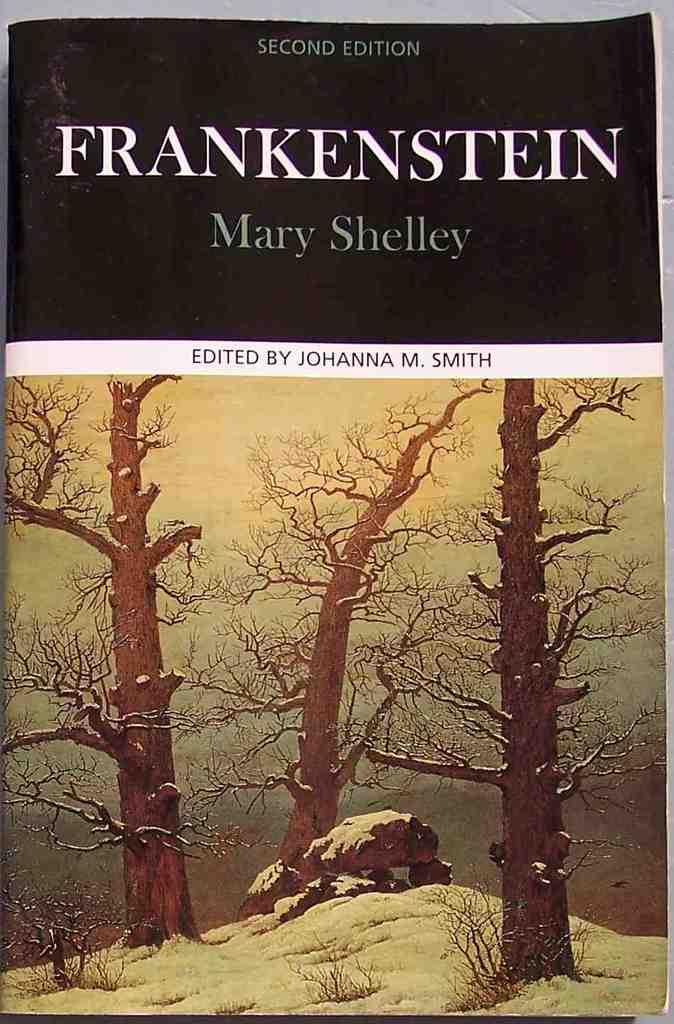Who is the author of frankenstein?
Provide a short and direct response. Mary shelley. Who edited this book?
Your answer should be compact. Johanna m. smith. 